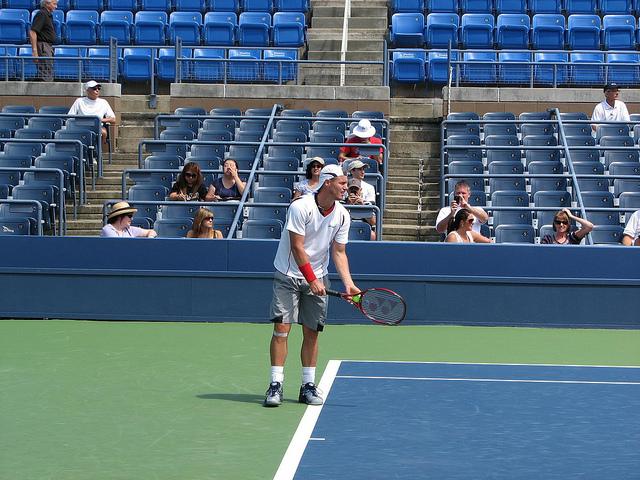What sport is being played?
Answer briefly. Tennis. Is there a crowd of people?
Answer briefly. Yes. What color is the tennis ball?
Write a very short answer. Yellow. 